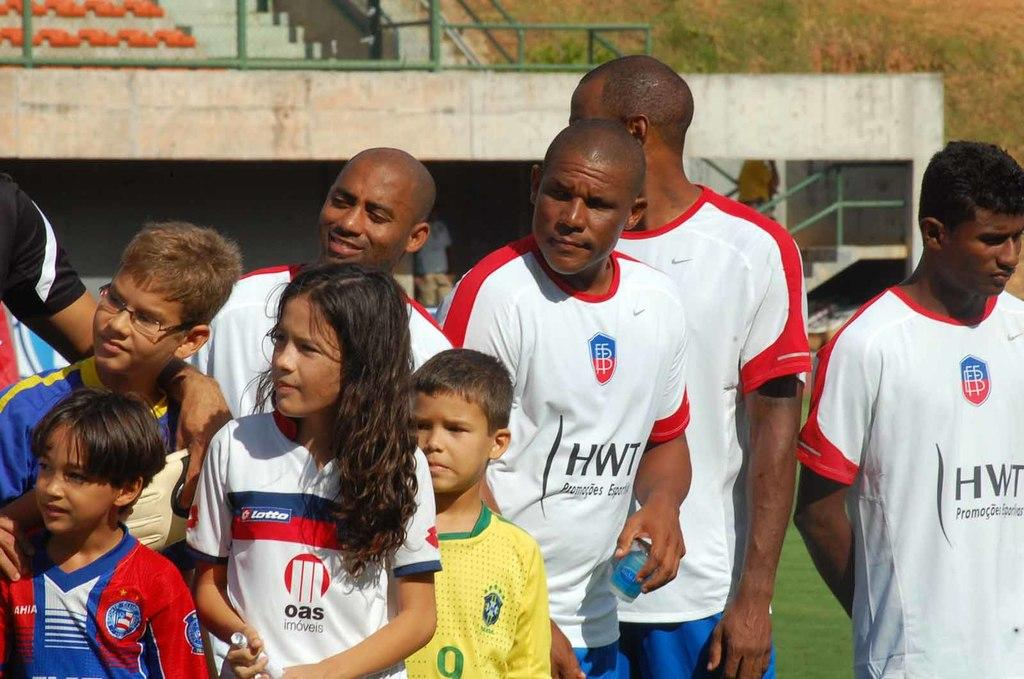<image>
Summarize the visual content of the image. Soccer players wearing HWT jerseys are standing next to children wearing different soccer jerseys. 